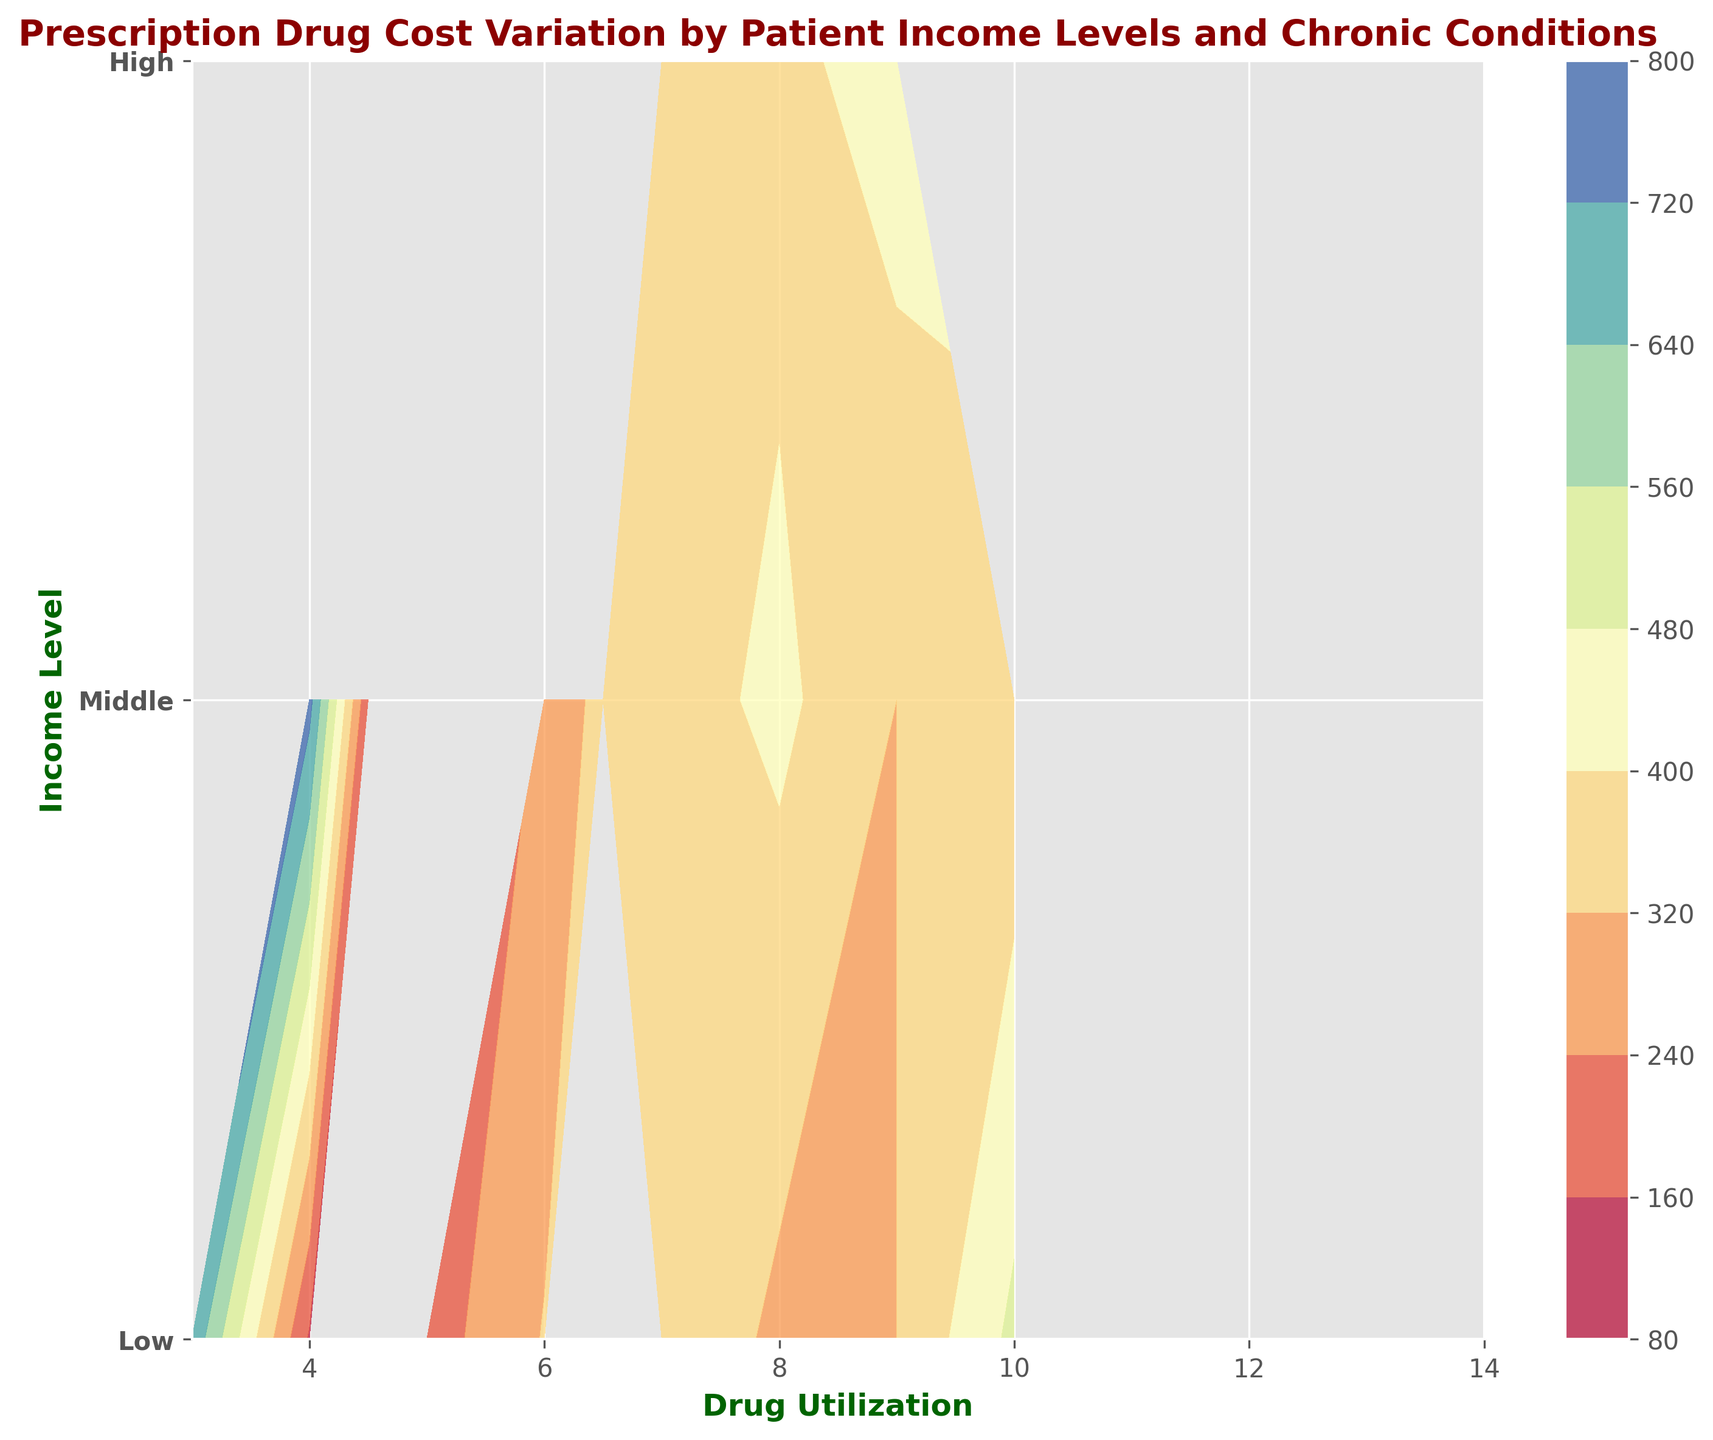What's the highest cost observed at the lowest income level for any drug utilization value? Locate the lowest income level on the y-axis (labeled "Low") and identify the contour regions. The highest cost at this level is indicated by the deepest color intensity within those regions.
Answer: 700 Which income level has the highest cost for a drug utilization of 5? Identify the x-axis value of 5 and compare the y-axis levels (Low, Middle, High) to see which has the darkest contour shade, indicating the highest cost.
Answer: High What is the average drug utilization for the highest cost observed? The highest cost is 800. Look at its corresponding region and identify the average x-axis value (drug utilization) within that contour region.
Answer: 5 For a drug utilization of 10, which income level has the lowest cost? Locate the x-axis value of 10 and compare the contour colors across the income levels. The lightest color corresponds to the lowest cost.
Answer: Low How does the cost for drug utilization of 9 compare between middle and high income levels? Find the x-axis value of 9 and compare the colors between the y-axis labels "Middle" and "High". Determine which has a darker color to assess higher costs.
Answer: High is higher What's the difference in cost between the highest and lowest income levels for a drug utilization value of 8? Identify the x-axis value of 8 and compare the darkest and lightest contour shades between the "Low" and "High" income levels. Subtract the cost associated with the lightest shade from the darkest shade.
Answer: 340 - 300 = 40 Which income level has the widest range of drug utilization values associated with costs over 500? Determine the contour region corresponding to costs over 500 and compare the width of these regions across the different income levels on the y-axis.
Answer: High Is there a visual trend in cost variation relative to increasing income levels for drug utilizations between 4 and 7? Observe the contour patterns as you move up the y-axis (representing increasing income levels) between x-axis values of 4 and 7. Look for any consistent changes in color intensity.
Answer: Costs generally increase Which income level shows the most uniform distribution of costs across all drug utilization values? Look for the y-axis income level where the contour colors remain relatively consistent across the x-axis (drug utilization values), indicating a uniform cost distribution.
Answer: Middle What can be inferred about the cost for chronic condition management for high-income patients compared to low-income patients? Compare the contour colors and their intensities at the "High" and "Low" income levels across various drug utilization values to understand the variation in costs.
Answer: Costs are generally higher for high-income patients 